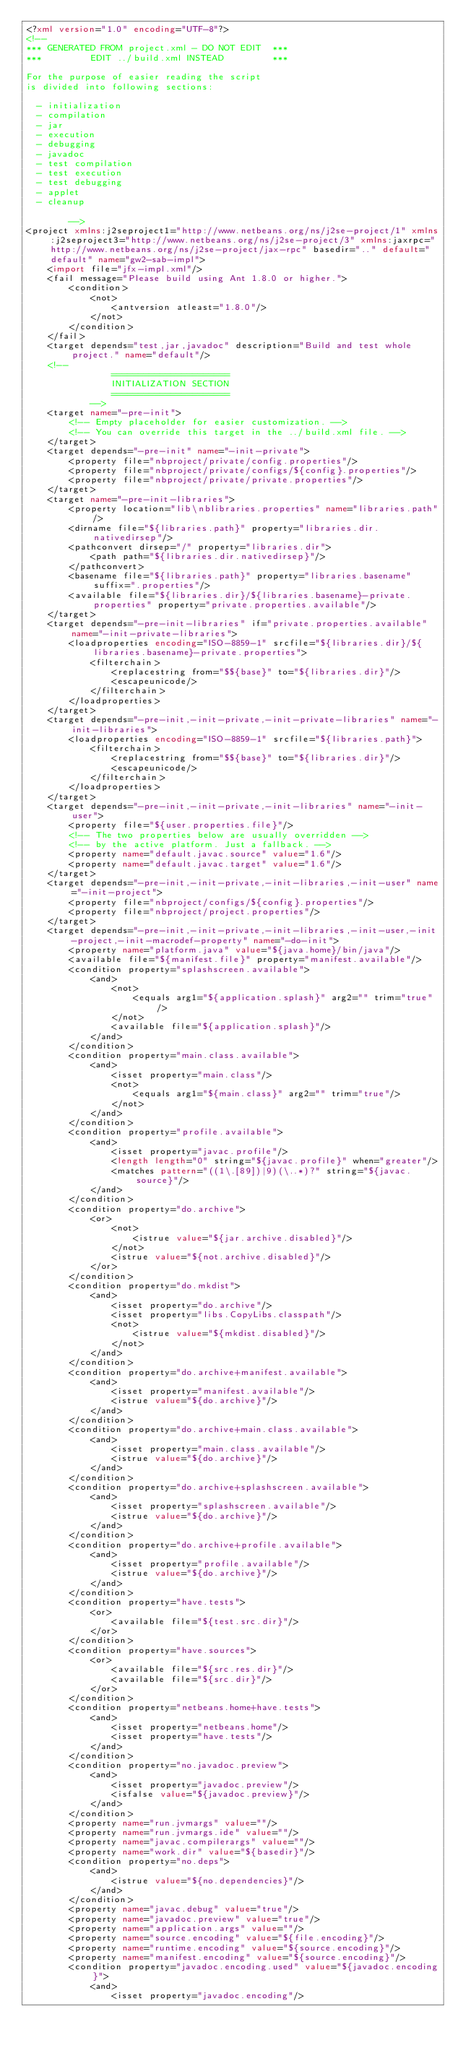Convert code to text. <code><loc_0><loc_0><loc_500><loc_500><_XML_><?xml version="1.0" encoding="UTF-8"?>
<!--
*** GENERATED FROM project.xml - DO NOT EDIT  ***
***         EDIT ../build.xml INSTEAD         ***

For the purpose of easier reading the script
is divided into following sections:

  - initialization
  - compilation
  - jar
  - execution
  - debugging
  - javadoc
  - test compilation
  - test execution
  - test debugging
  - applet
  - cleanup

        -->
<project xmlns:j2seproject1="http://www.netbeans.org/ns/j2se-project/1" xmlns:j2seproject3="http://www.netbeans.org/ns/j2se-project/3" xmlns:jaxrpc="http://www.netbeans.org/ns/j2se-project/jax-rpc" basedir=".." default="default" name="gw2-sab-impl">
    <import file="jfx-impl.xml"/>
    <fail message="Please build using Ant 1.8.0 or higher.">
        <condition>
            <not>
                <antversion atleast="1.8.0"/>
            </not>
        </condition>
    </fail>
    <target depends="test,jar,javadoc" description="Build and test whole project." name="default"/>
    <!-- 
                ======================
                INITIALIZATION SECTION 
                ======================
            -->
    <target name="-pre-init">
        <!-- Empty placeholder for easier customization. -->
        <!-- You can override this target in the ../build.xml file. -->
    </target>
    <target depends="-pre-init" name="-init-private">
        <property file="nbproject/private/config.properties"/>
        <property file="nbproject/private/configs/${config}.properties"/>
        <property file="nbproject/private/private.properties"/>
    </target>
    <target name="-pre-init-libraries">
        <property location="lib\nblibraries.properties" name="libraries.path"/>
        <dirname file="${libraries.path}" property="libraries.dir.nativedirsep"/>
        <pathconvert dirsep="/" property="libraries.dir">
            <path path="${libraries.dir.nativedirsep}"/>
        </pathconvert>
        <basename file="${libraries.path}" property="libraries.basename" suffix=".properties"/>
        <available file="${libraries.dir}/${libraries.basename}-private.properties" property="private.properties.available"/>
    </target>
    <target depends="-pre-init-libraries" if="private.properties.available" name="-init-private-libraries">
        <loadproperties encoding="ISO-8859-1" srcfile="${libraries.dir}/${libraries.basename}-private.properties">
            <filterchain>
                <replacestring from="$${base}" to="${libraries.dir}"/>
                <escapeunicode/>
            </filterchain>
        </loadproperties>
    </target>
    <target depends="-pre-init,-init-private,-init-private-libraries" name="-init-libraries">
        <loadproperties encoding="ISO-8859-1" srcfile="${libraries.path}">
            <filterchain>
                <replacestring from="$${base}" to="${libraries.dir}"/>
                <escapeunicode/>
            </filterchain>
        </loadproperties>
    </target>
    <target depends="-pre-init,-init-private,-init-libraries" name="-init-user">
        <property file="${user.properties.file}"/>
        <!-- The two properties below are usually overridden -->
        <!-- by the active platform. Just a fallback. -->
        <property name="default.javac.source" value="1.6"/>
        <property name="default.javac.target" value="1.6"/>
    </target>
    <target depends="-pre-init,-init-private,-init-libraries,-init-user" name="-init-project">
        <property file="nbproject/configs/${config}.properties"/>
        <property file="nbproject/project.properties"/>
    </target>
    <target depends="-pre-init,-init-private,-init-libraries,-init-user,-init-project,-init-macrodef-property" name="-do-init">
        <property name="platform.java" value="${java.home}/bin/java"/>
        <available file="${manifest.file}" property="manifest.available"/>
        <condition property="splashscreen.available">
            <and>
                <not>
                    <equals arg1="${application.splash}" arg2="" trim="true"/>
                </not>
                <available file="${application.splash}"/>
            </and>
        </condition>
        <condition property="main.class.available">
            <and>
                <isset property="main.class"/>
                <not>
                    <equals arg1="${main.class}" arg2="" trim="true"/>
                </not>
            </and>
        </condition>
        <condition property="profile.available">
            <and>
                <isset property="javac.profile"/>
                <length length="0" string="${javac.profile}" when="greater"/>
                <matches pattern="((1\.[89])|9)(\..*)?" string="${javac.source}"/>
            </and>
        </condition>
        <condition property="do.archive">
            <or>
                <not>
                    <istrue value="${jar.archive.disabled}"/>
                </not>
                <istrue value="${not.archive.disabled}"/>
            </or>
        </condition>
        <condition property="do.mkdist">
            <and>
                <isset property="do.archive"/>
                <isset property="libs.CopyLibs.classpath"/>
                <not>
                    <istrue value="${mkdist.disabled}"/>
                </not>
            </and>
        </condition>
        <condition property="do.archive+manifest.available">
            <and>
                <isset property="manifest.available"/>
                <istrue value="${do.archive}"/>
            </and>
        </condition>
        <condition property="do.archive+main.class.available">
            <and>
                <isset property="main.class.available"/>
                <istrue value="${do.archive}"/>
            </and>
        </condition>
        <condition property="do.archive+splashscreen.available">
            <and>
                <isset property="splashscreen.available"/>
                <istrue value="${do.archive}"/>
            </and>
        </condition>
        <condition property="do.archive+profile.available">
            <and>
                <isset property="profile.available"/>
                <istrue value="${do.archive}"/>
            </and>
        </condition>
        <condition property="have.tests">
            <or>
                <available file="${test.src.dir}"/>
            </or>
        </condition>
        <condition property="have.sources">
            <or>
                <available file="${src.res.dir}"/>
                <available file="${src.dir}"/>
            </or>
        </condition>
        <condition property="netbeans.home+have.tests">
            <and>
                <isset property="netbeans.home"/>
                <isset property="have.tests"/>
            </and>
        </condition>
        <condition property="no.javadoc.preview">
            <and>
                <isset property="javadoc.preview"/>
                <isfalse value="${javadoc.preview}"/>
            </and>
        </condition>
        <property name="run.jvmargs" value=""/>
        <property name="run.jvmargs.ide" value=""/>
        <property name="javac.compilerargs" value=""/>
        <property name="work.dir" value="${basedir}"/>
        <condition property="no.deps">
            <and>
                <istrue value="${no.dependencies}"/>
            </and>
        </condition>
        <property name="javac.debug" value="true"/>
        <property name="javadoc.preview" value="true"/>
        <property name="application.args" value=""/>
        <property name="source.encoding" value="${file.encoding}"/>
        <property name="runtime.encoding" value="${source.encoding}"/>
        <property name="manifest.encoding" value="${source.encoding}"/>
        <condition property="javadoc.encoding.used" value="${javadoc.encoding}">
            <and>
                <isset property="javadoc.encoding"/></code> 